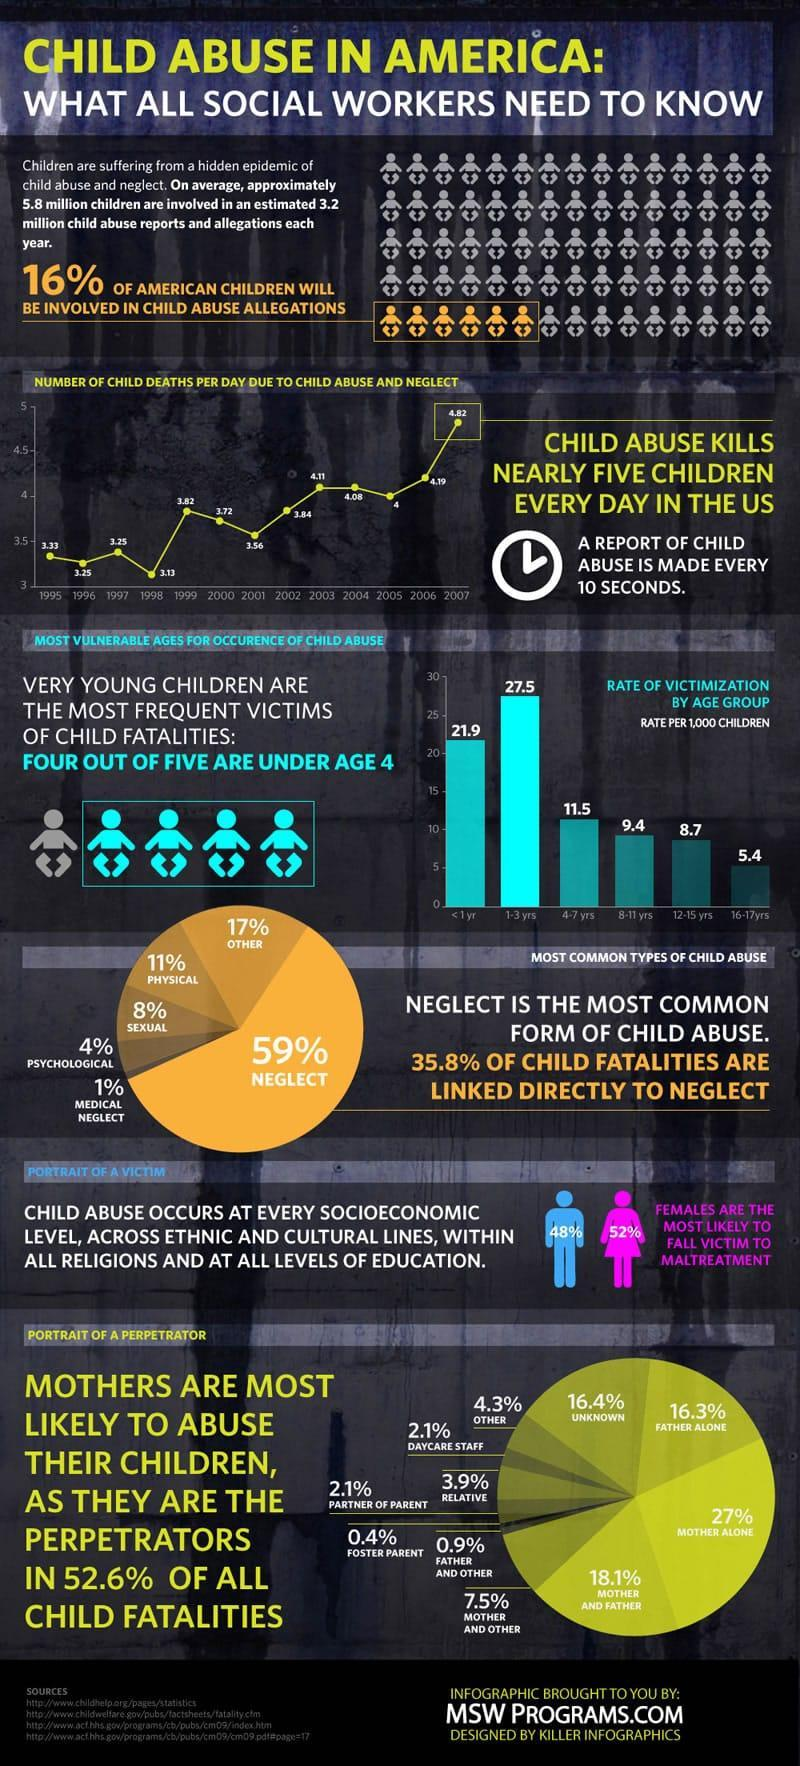What percentage of abuse is carried out by daycare staff and relatives?
Answer the question with a short phrase. 6.0% What number per 1000 children in the age group 1-3 yrs are victimized? 27.5 Which year had the highest number of child deaths due to child abuse and neglect? 2007 